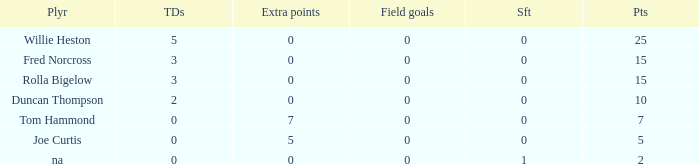Parse the table in full. {'header': ['Plyr', 'TDs', 'Extra points', 'Field goals', 'Sft', 'Pts'], 'rows': [['Willie Heston', '5', '0', '0', '0', '25'], ['Fred Norcross', '3', '0', '0', '0', '15'], ['Rolla Bigelow', '3', '0', '0', '0', '15'], ['Duncan Thompson', '2', '0', '0', '0', '10'], ['Tom Hammond', '0', '7', '0', '0', '7'], ['Joe Curtis', '0', '5', '0', '0', '5'], ['na', '0', '0', '0', '1', '2']]} How many Touchdowns have a Player of rolla bigelow, and an Extra points smaller than 0? None. 